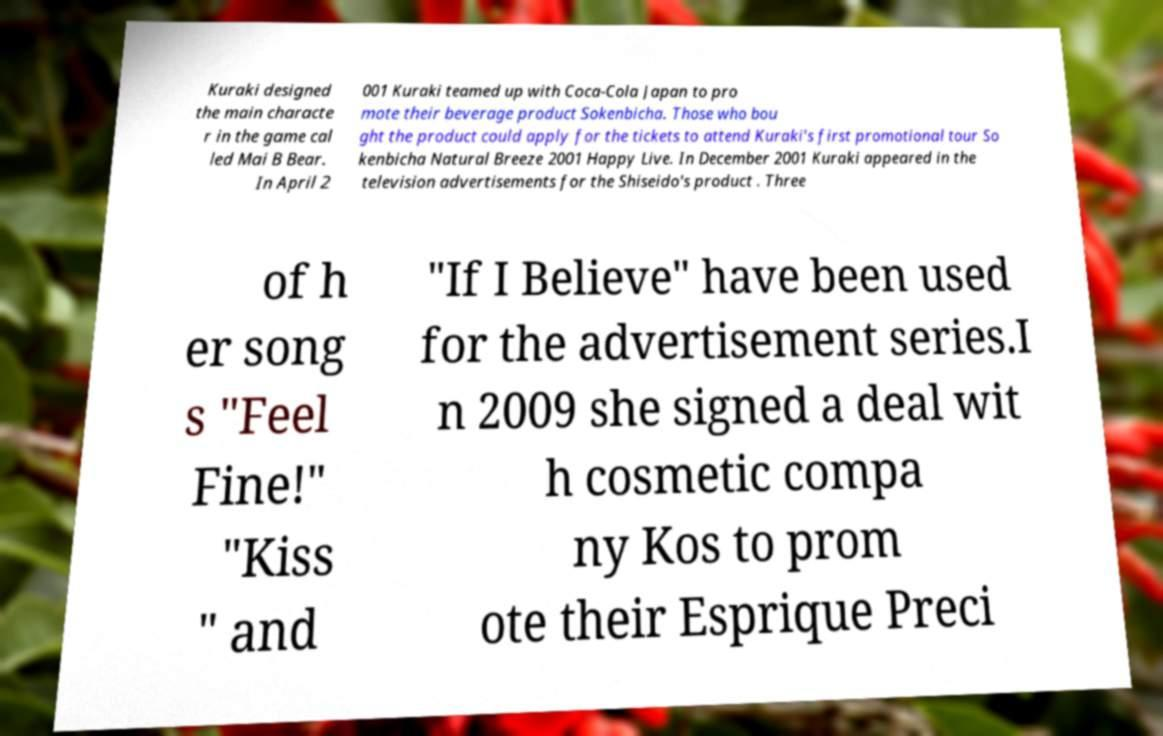Could you extract and type out the text from this image? Kuraki designed the main characte r in the game cal led Mai B Bear. In April 2 001 Kuraki teamed up with Coca-Cola Japan to pro mote their beverage product Sokenbicha. Those who bou ght the product could apply for the tickets to attend Kuraki's first promotional tour So kenbicha Natural Breeze 2001 Happy Live. In December 2001 Kuraki appeared in the television advertisements for the Shiseido's product . Three of h er song s "Feel Fine!" "Kiss " and "If I Believe" have been used for the advertisement series.I n 2009 she signed a deal wit h cosmetic compa ny Kos to prom ote their Esprique Preci 